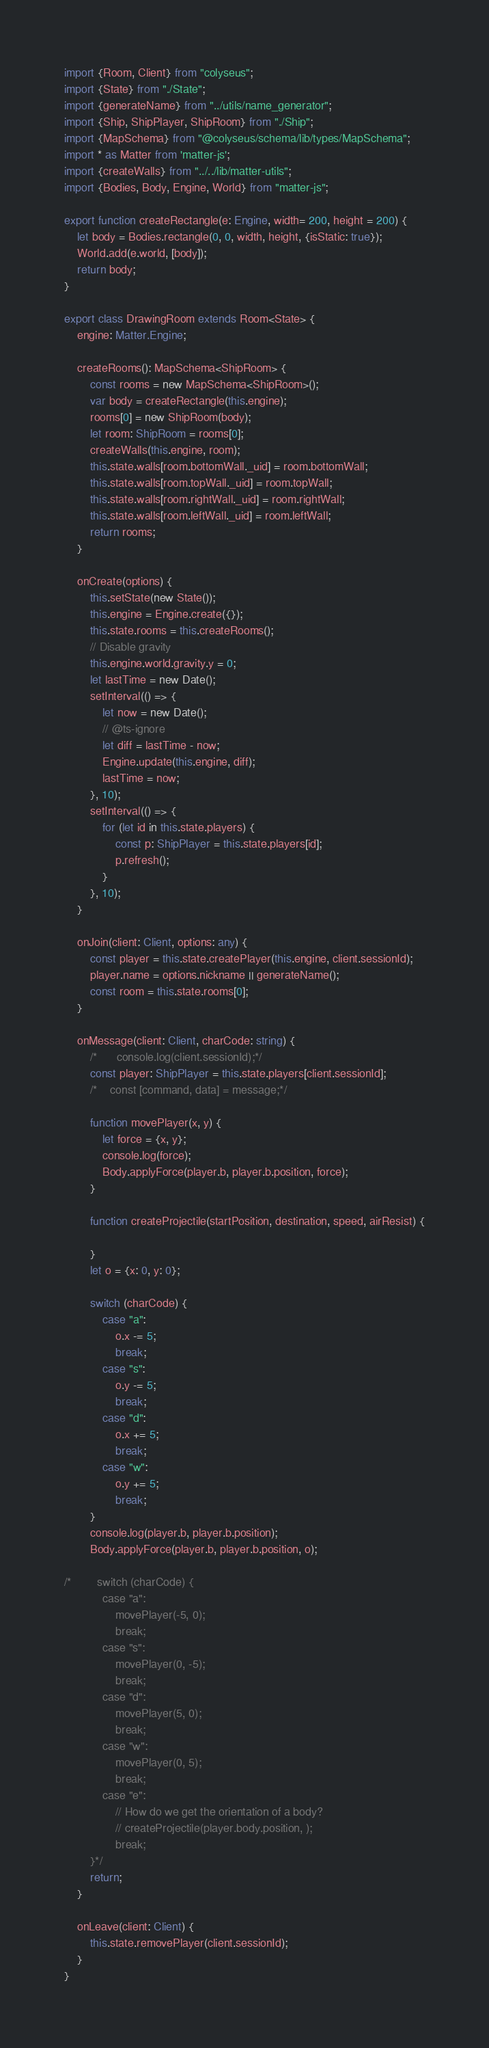<code> <loc_0><loc_0><loc_500><loc_500><_TypeScript_>import {Room, Client} from "colyseus";
import {State} from "./State";
import {generateName} from "../utils/name_generator";
import {Ship, ShipPlayer, ShipRoom} from "./Ship";
import {MapSchema} from "@colyseus/schema/lib/types/MapSchema";
import * as Matter from 'matter-js';
import {createWalls} from "../../lib/matter-utils";
import {Bodies, Body, Engine, World} from "matter-js";

export function createRectangle(e: Engine, width= 200, height = 200) {
    let body = Bodies.rectangle(0, 0, width, height, {isStatic: true});
    World.add(e.world, [body]);
    return body;
}

export class DrawingRoom extends Room<State> {
    engine: Matter.Engine;

    createRooms(): MapSchema<ShipRoom> {
        const rooms = new MapSchema<ShipRoom>();
        var body = createRectangle(this.engine);
        rooms[0] = new ShipRoom(body);
        let room: ShipRoom = rooms[0];
        createWalls(this.engine, room);
        this.state.walls[room.bottomWall._uid] = room.bottomWall;
        this.state.walls[room.topWall._uid] = room.topWall;
        this.state.walls[room.rightWall._uid] = room.rightWall;
        this.state.walls[room.leftWall._uid] = room.leftWall;
        return rooms;
    }

    onCreate(options) {
        this.setState(new State());
        this.engine = Engine.create({});
        this.state.rooms = this.createRooms();
        // Disable gravity
        this.engine.world.gravity.y = 0;
        let lastTime = new Date();
        setInterval(() => {
            let now = new Date();
            // @ts-ignore
            let diff = lastTime - now;
            Engine.update(this.engine, diff);
            lastTime = now;
        }, 10);
        setInterval(() => {
            for (let id in this.state.players) {
                const p: ShipPlayer = this.state.players[id];
                p.refresh();
            }
        }, 10);
    }

    onJoin(client: Client, options: any) {
        const player = this.state.createPlayer(this.engine, client.sessionId);
        player.name = options.nickname || generateName();
        const room = this.state.rooms[0];
    }

    onMessage(client: Client, charCode: string) {
        /*      console.log(client.sessionId);*/
        const player: ShipPlayer = this.state.players[client.sessionId];
        /*    const [command, data] = message;*/

        function movePlayer(x, y) {
            let force = {x, y};
            console.log(force);
            Body.applyForce(player.b, player.b.position, force);
        }

        function createProjectile(startPosition, destination, speed, airResist) {

        }
        let o = {x: 0, y: 0};

        switch (charCode) {
            case "a":
                o.x -= 5;
                break;
            case "s":
                o.y -= 5;
                break;
            case "d":
                o.x += 5;
                break;
            case "w":
                o.y += 5;
                break;
        }
        console.log(player.b, player.b.position);
        Body.applyForce(player.b, player.b.position, o);

/*        switch (charCode) {
            case "a":
                movePlayer(-5, 0);
                break;
            case "s":
                movePlayer(0, -5);
                break;
            case "d":
                movePlayer(5, 0);
                break;
            case "w":
                movePlayer(0, 5);
                break;
            case "e":
                // How do we get the orientation of a body?
                // createProjectile(player.body.position, );
                break;
        }*/
        return;
    }

    onLeave(client: Client) {
        this.state.removePlayer(client.sessionId);
    }
}
</code> 